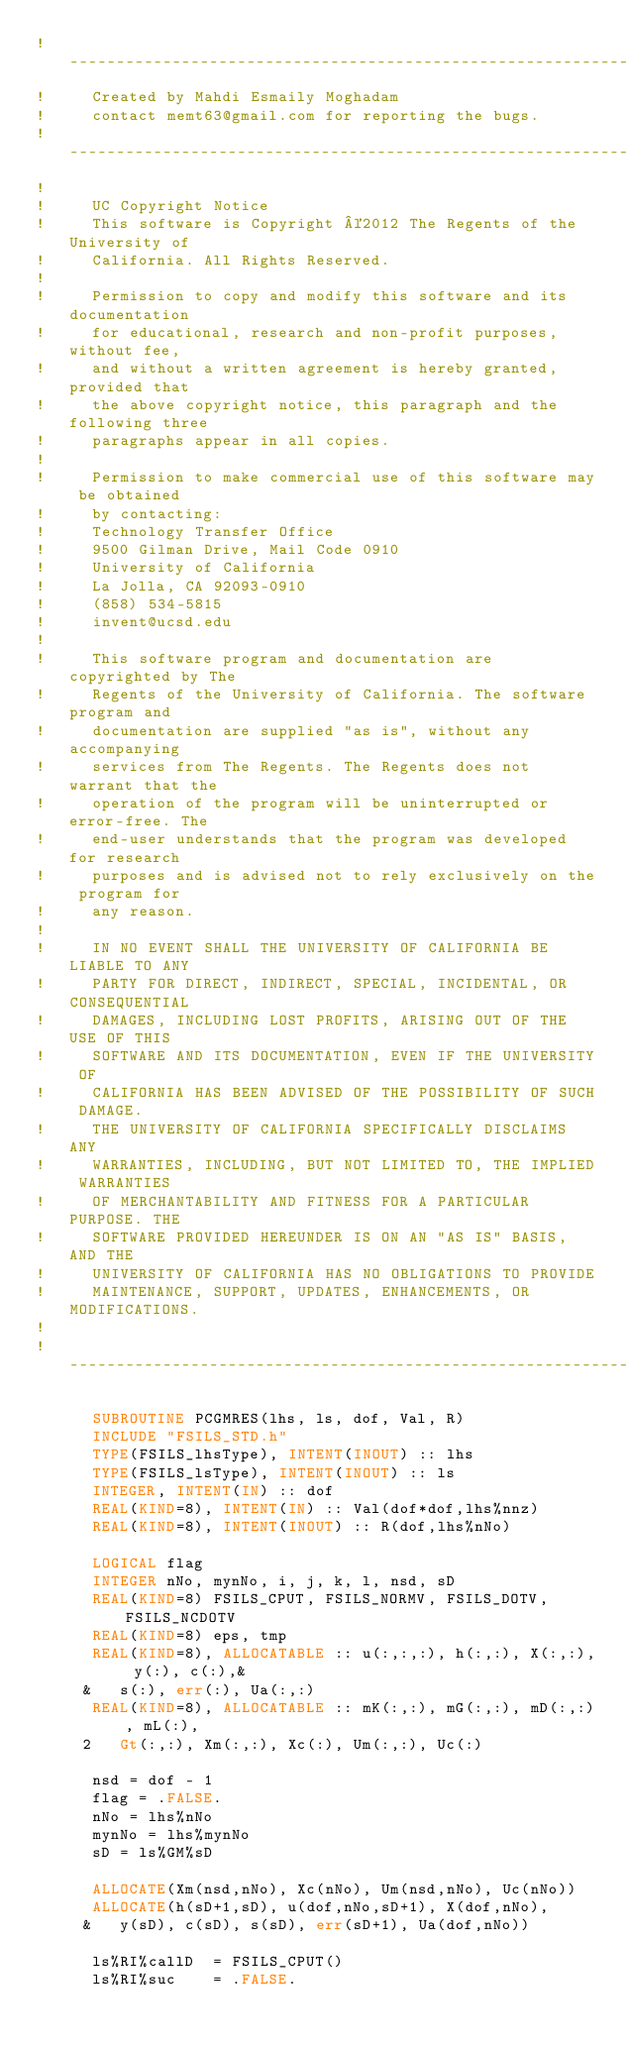Convert code to text. <code><loc_0><loc_0><loc_500><loc_500><_FORTRAN_>!--------------------------------------------------------------------
!     Created by Mahdi Esmaily Moghadam
!     contact memt63@gmail.com for reporting the bugs.
!--------------------------------------------------------------------
!
!     UC Copyright Notice
!     This software is Copyright ©2012 The Regents of the University of
!     California. All Rights Reserved.
!
!     Permission to copy and modify this software and its documentation
!     for educational, research and non-profit purposes, without fee,
!     and without a written agreement is hereby granted, provided that
!     the above copyright notice, this paragraph and the following three
!     paragraphs appear in all copies.
!
!     Permission to make commercial use of this software may be obtained
!     by contacting:
!     Technology Transfer Office
!     9500 Gilman Drive, Mail Code 0910
!     University of California
!     La Jolla, CA 92093-0910
!     (858) 534-5815
!     invent@ucsd.edu
!
!     This software program and documentation are copyrighted by The
!     Regents of the University of California. The software program and
!     documentation are supplied "as is", without any accompanying
!     services from The Regents. The Regents does not warrant that the
!     operation of the program will be uninterrupted or error-free. The
!     end-user understands that the program was developed for research
!     purposes and is advised not to rely exclusively on the program for
!     any reason.
!
!     IN NO EVENT SHALL THE UNIVERSITY OF CALIFORNIA BE LIABLE TO ANY
!     PARTY FOR DIRECT, INDIRECT, SPECIAL, INCIDENTAL, OR CONSEQUENTIAL
!     DAMAGES, INCLUDING LOST PROFITS, ARISING OUT OF THE USE OF THIS
!     SOFTWARE AND ITS DOCUMENTATION, EVEN IF THE UNIVERSITY OF
!     CALIFORNIA HAS BEEN ADVISED OF THE POSSIBILITY OF SUCH DAMAGE.
!     THE UNIVERSITY OF CALIFORNIA SPECIFICALLY DISCLAIMS ANY
!     WARRANTIES, INCLUDING, BUT NOT LIMITED TO, THE IMPLIED WARRANTIES
!     OF MERCHANTABILITY AND FITNESS FOR A PARTICULAR PURPOSE. THE
!     SOFTWARE PROVIDED HEREUNDER IS ON AN "AS IS" BASIS, AND THE
!     UNIVERSITY OF CALIFORNIA HAS NO OBLIGATIONS TO PROVIDE
!     MAINTENANCE, SUPPORT, UPDATES, ENHANCEMENTS, OR MODIFICATIONS.
!
!--------------------------------------------------------------------

      SUBROUTINE PCGMRES(lhs, ls, dof, Val, R)
      INCLUDE "FSILS_STD.h"
      TYPE(FSILS_lhsType), INTENT(INOUT) :: lhs
      TYPE(FSILS_lsType), INTENT(INOUT) :: ls
      INTEGER, INTENT(IN) :: dof
      REAL(KIND=8), INTENT(IN) :: Val(dof*dof,lhs%nnz)
      REAL(KIND=8), INTENT(INOUT) :: R(dof,lhs%nNo)

      LOGICAL flag
      INTEGER nNo, mynNo, i, j, k, l, nsd, sD
      REAL(KIND=8) FSILS_CPUT, FSILS_NORMV, FSILS_DOTV, FSILS_NCDOTV
      REAL(KIND=8) eps, tmp
      REAL(KIND=8), ALLOCATABLE :: u(:,:,:), h(:,:), X(:,:), y(:), c(:),&
     &   s(:), err(:), Ua(:,:)
      REAL(KIND=8), ALLOCATABLE :: mK(:,:), mG(:,:), mD(:,:), mL(:),
     2   Gt(:,:), Xm(:,:), Xc(:), Um(:,:), Uc(:)

      nsd = dof - 1
      flag = .FALSE.
      nNo = lhs%nNo
      mynNo = lhs%mynNo
      sD = ls%GM%sD

      ALLOCATE(Xm(nsd,nNo), Xc(nNo), Um(nsd,nNo), Uc(nNo))
      ALLOCATE(h(sD+1,sD), u(dof,nNo,sD+1), X(dof,nNo),
     &   y(sD), c(sD), s(sD), err(sD+1), Ua(dof,nNo))

      ls%RI%callD  = FSILS_CPUT()
      ls%RI%suc    = .FALSE.</code> 